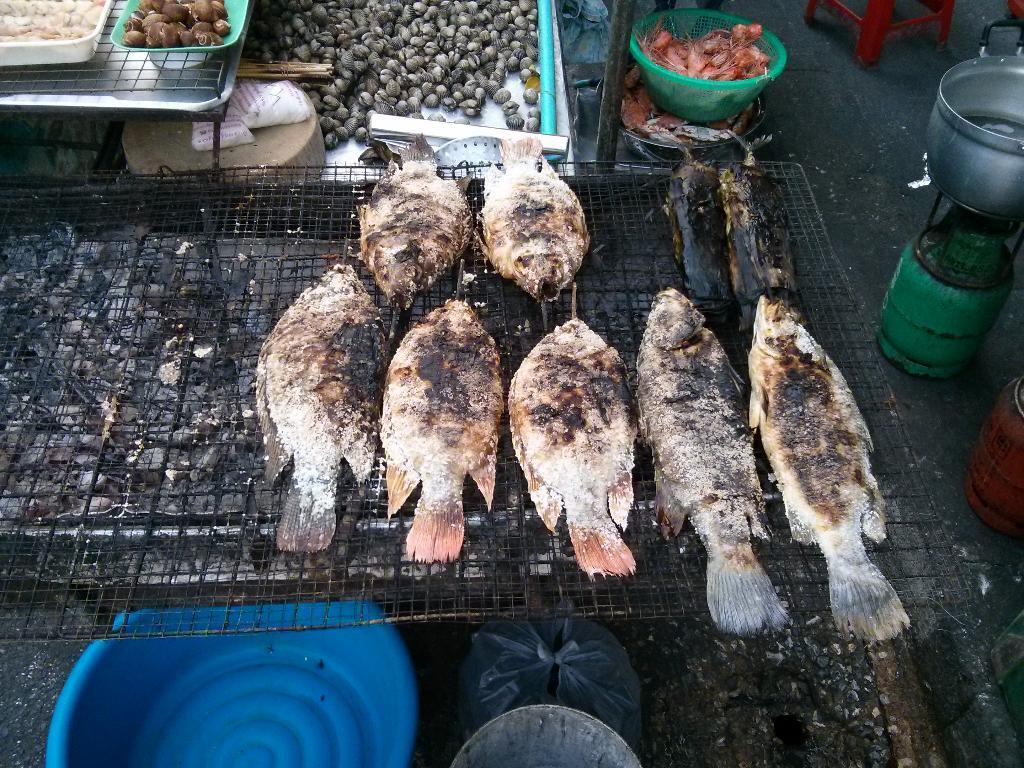What type of animals can be seen in the image? There are fishes in the image. What object is present in the image that has a cylindrical shape? There is a cylinder in the image. What is placed on top of the cylinder? There is a vessel on the cylinder. What is located on the ground in the image? There is a tub on the ground in the image. What can be found in the basket in the image? There is a basket with food items in the image. Where is the aunt sitting with her cats in the image? There is no aunt or cats present in the image. What type of leaf can be seen falling from the tree in the image? There is no tree or leaf present in the image. 